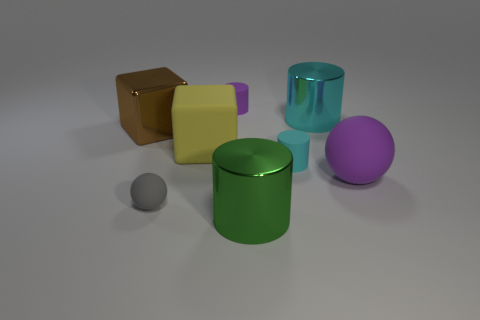Subtract all cyan cylinders. How many were subtracted if there are1cyan cylinders left? 1 Subtract 1 cubes. How many cubes are left? 1 Add 2 tiny brown shiny blocks. How many objects exist? 10 Subtract all brown blocks. How many blocks are left? 1 Subtract all purple blocks. How many green balls are left? 0 Subtract all large metallic things. Subtract all gray spheres. How many objects are left? 4 Add 4 brown metal blocks. How many brown metal blocks are left? 5 Add 8 tiny spheres. How many tiny spheres exist? 9 Subtract 0 yellow cylinders. How many objects are left? 8 Subtract all spheres. How many objects are left? 6 